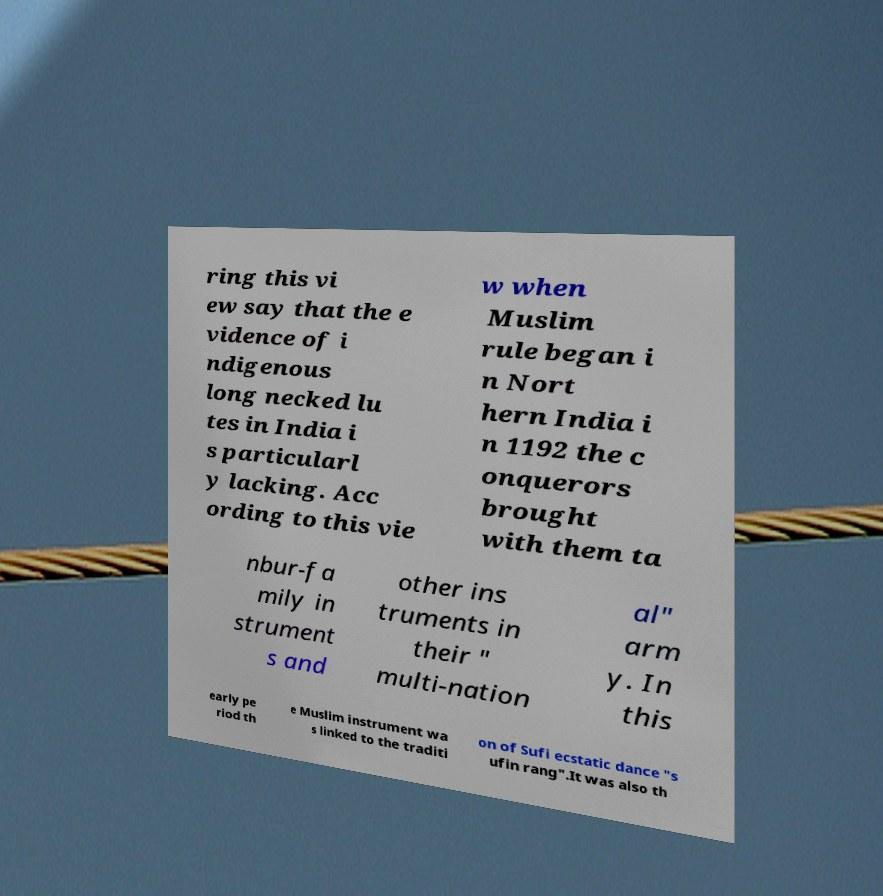Can you read and provide the text displayed in the image?This photo seems to have some interesting text. Can you extract and type it out for me? ring this vi ew say that the e vidence of i ndigenous long necked lu tes in India i s particularl y lacking. Acc ording to this vie w when Muslim rule began i n Nort hern India i n 1192 the c onquerors brought with them ta nbur-fa mily in strument s and other ins truments in their " multi-nation al" arm y. In this early pe riod th e Muslim instrument wa s linked to the traditi on of Sufi ecstatic dance "s ufin rang".It was also th 